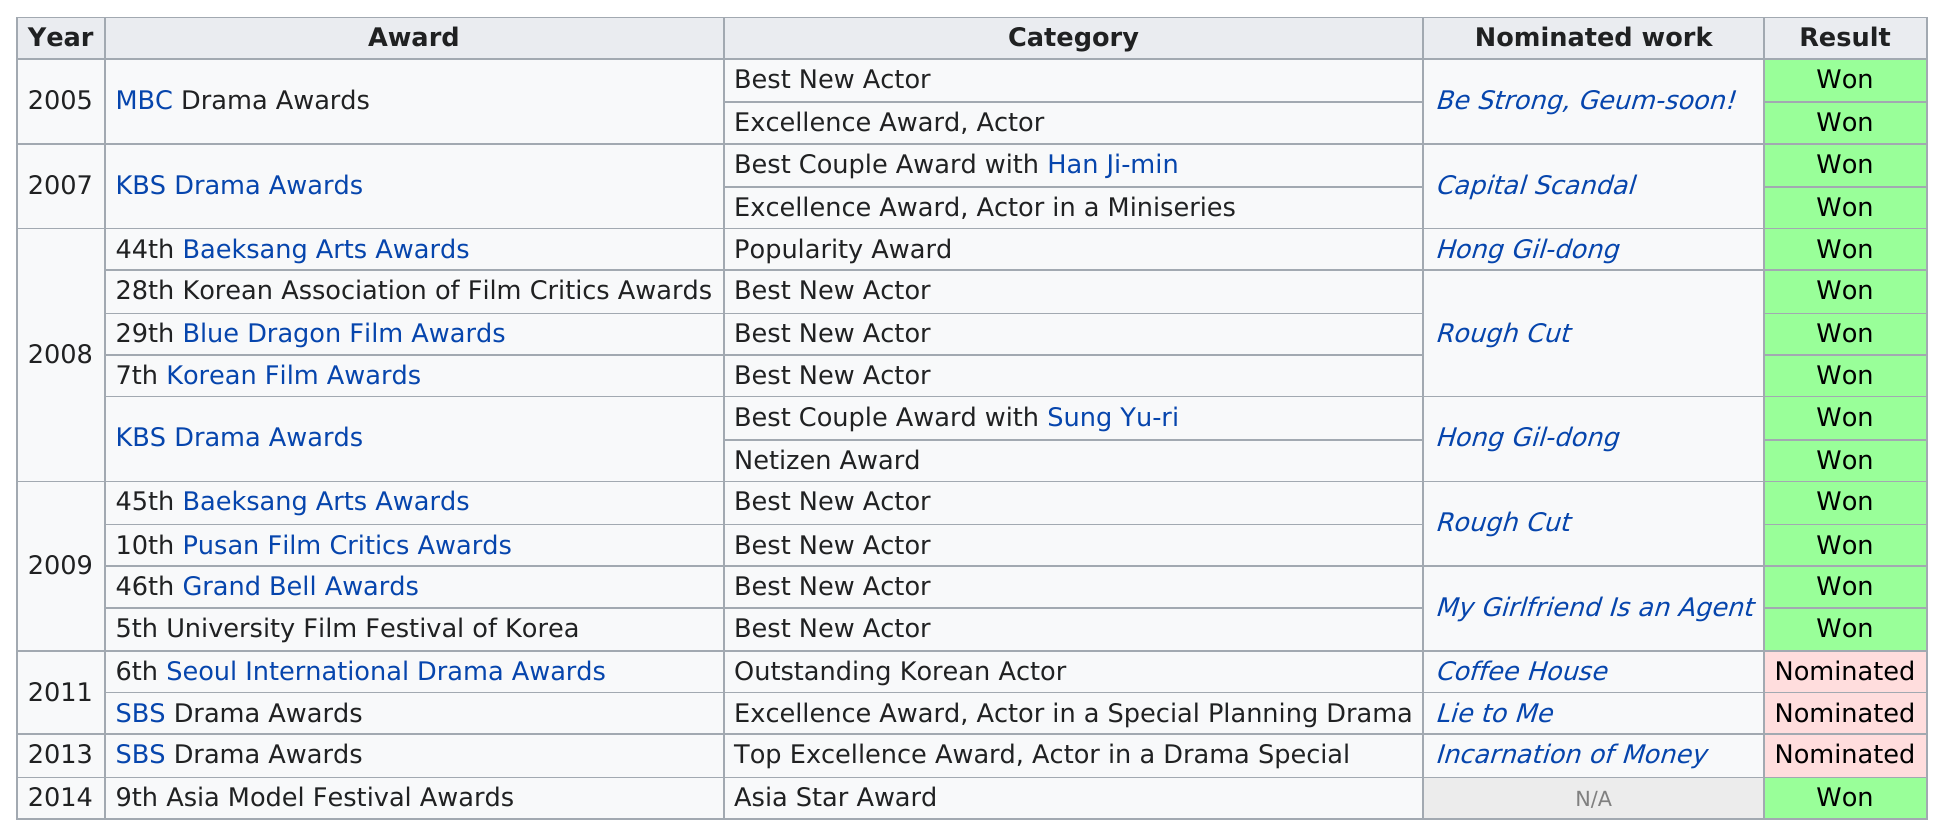Highlight a few significant elements in this photo. Another movie that won an award for Chris Weitz in 2008 was not rough cut, it was Hong Gil-dong. This actor has won a total of 15 awards. Kang won a total of 6 awards in 2008. Before 2010, Kang Ji-hwan won a total of 14 awards. The Asia Model Festival Awards is the 9th award listed. 